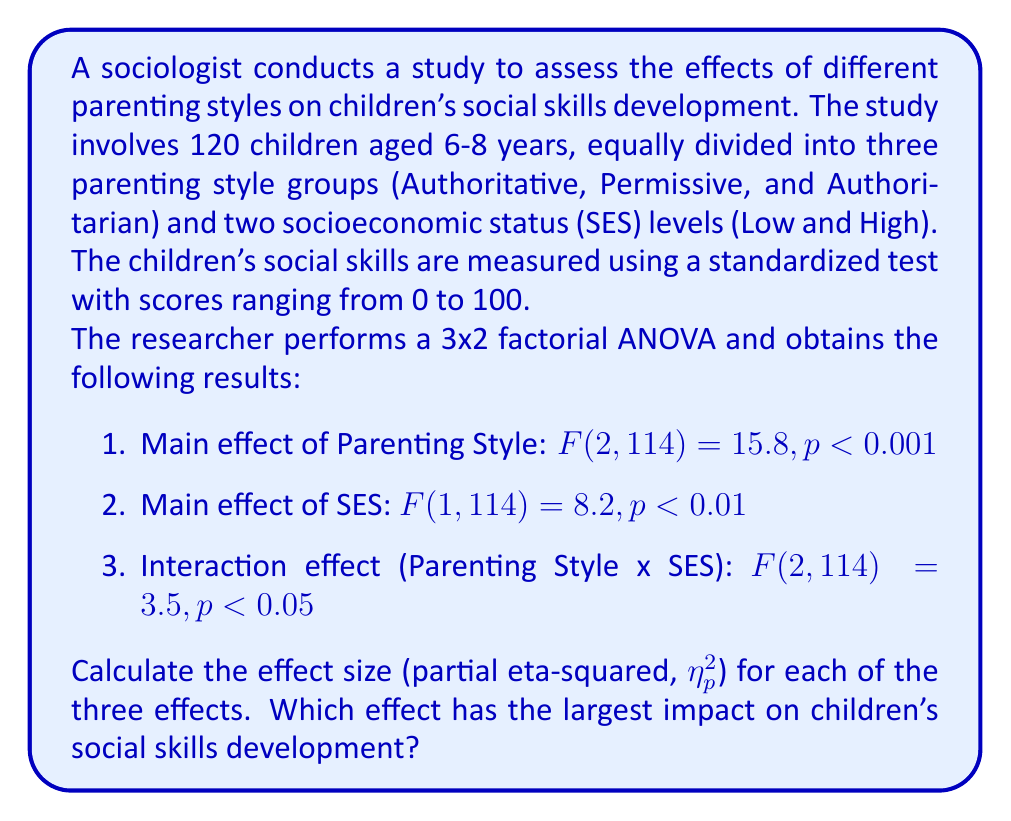Could you help me with this problem? To calculate the partial eta-squared ($\eta_p^2$) for each effect, we'll use the formula:

$$\eta_p^2 = \frac{F \times df_{effect}}{F \times df_{effect} + df_{error}}$$

Where $F$ is the F-value, $df_{effect}$ is the degrees of freedom for the effect, and $df_{error}$ is the degrees of freedom for the error term.

1. For the main effect of Parenting Style:
   $df_{effect} = 2$, $df_{error} = 114$, $F = 15.8$
   
   $$\eta_p^2 = \frac{15.8 \times 2}{15.8 \times 2 + 114} = \frac{31.6}{145.6} = 0.217$$

2. For the main effect of SES:
   $df_{effect} = 1$, $df_{error} = 114$, $F = 8.2$
   
   $$\eta_p^2 = \frac{8.2 \times 1}{8.2 \times 1 + 114} = \frac{8.2}{122.2} = 0.067$$

3. For the interaction effect (Parenting Style x SES):
   $df_{effect} = 2$, $df_{error} = 114$, $F = 3.5$
   
   $$\eta_p^2 = \frac{3.5 \times 2}{3.5 \times 2 + 114} = \frac{7}{121} = 0.058$$

Comparing the effect sizes:
1. Parenting Style: $\eta_p^2 = 0.217$
2. SES: $\eta_p^2 = 0.067$
3. Interaction (Parenting Style x SES): $\eta_p^2 = 0.058$

The largest effect size is for the main effect of Parenting Style ($\eta_p^2 = 0.217$), indicating that it has the largest impact on children's social skills development among the three effects analyzed.
Answer: The effect sizes (partial eta-squared) are:
1. Parenting Style: $\eta_p^2 = 0.217$
2. SES: $\eta_p^2 = 0.067$
3. Interaction (Parenting Style x SES): $\eta_p^2 = 0.058$

The main effect of Parenting Style has the largest impact on children's social skills development, with $\eta_p^2 = 0.217$. 